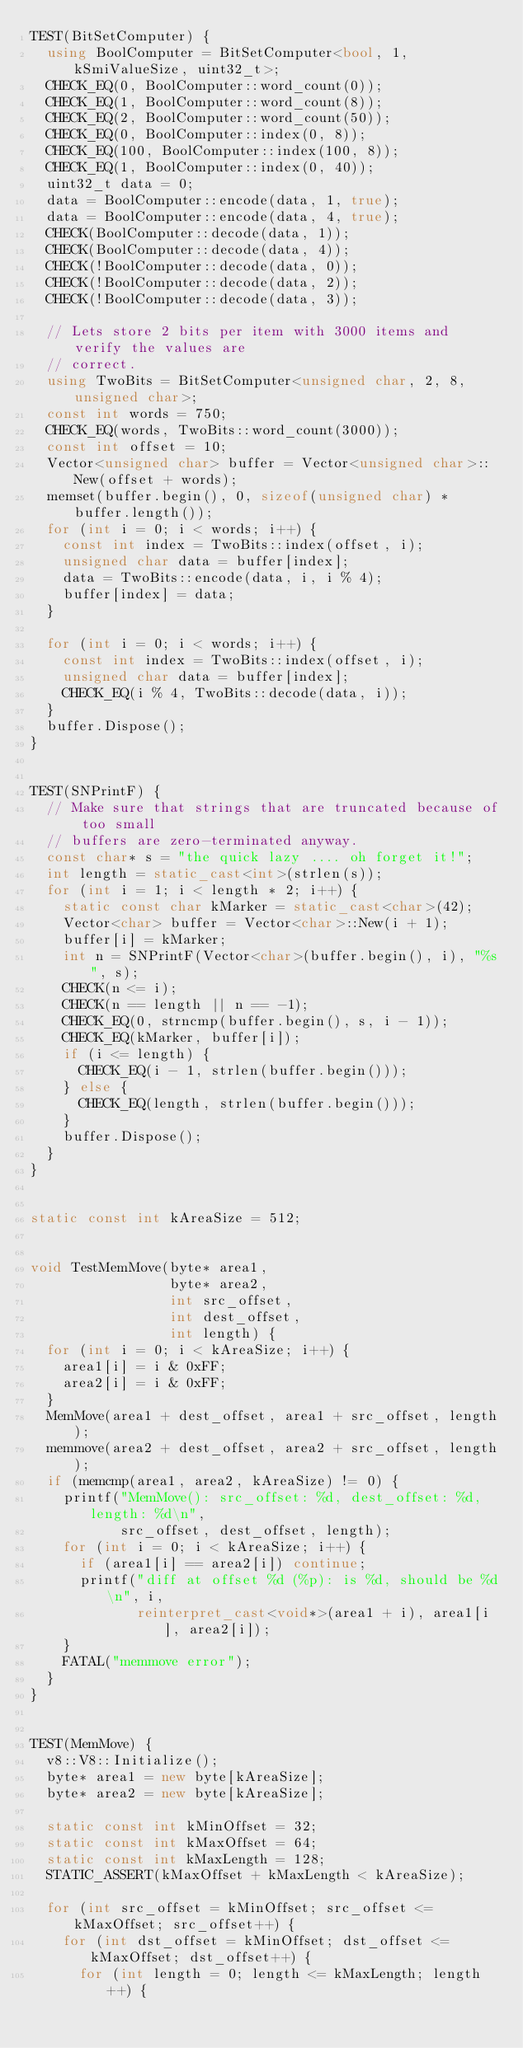<code> <loc_0><loc_0><loc_500><loc_500><_C++_>TEST(BitSetComputer) {
  using BoolComputer = BitSetComputer<bool, 1, kSmiValueSize, uint32_t>;
  CHECK_EQ(0, BoolComputer::word_count(0));
  CHECK_EQ(1, BoolComputer::word_count(8));
  CHECK_EQ(2, BoolComputer::word_count(50));
  CHECK_EQ(0, BoolComputer::index(0, 8));
  CHECK_EQ(100, BoolComputer::index(100, 8));
  CHECK_EQ(1, BoolComputer::index(0, 40));
  uint32_t data = 0;
  data = BoolComputer::encode(data, 1, true);
  data = BoolComputer::encode(data, 4, true);
  CHECK(BoolComputer::decode(data, 1));
  CHECK(BoolComputer::decode(data, 4));
  CHECK(!BoolComputer::decode(data, 0));
  CHECK(!BoolComputer::decode(data, 2));
  CHECK(!BoolComputer::decode(data, 3));

  // Lets store 2 bits per item with 3000 items and verify the values are
  // correct.
  using TwoBits = BitSetComputer<unsigned char, 2, 8, unsigned char>;
  const int words = 750;
  CHECK_EQ(words, TwoBits::word_count(3000));
  const int offset = 10;
  Vector<unsigned char> buffer = Vector<unsigned char>::New(offset + words);
  memset(buffer.begin(), 0, sizeof(unsigned char) * buffer.length());
  for (int i = 0; i < words; i++) {
    const int index = TwoBits::index(offset, i);
    unsigned char data = buffer[index];
    data = TwoBits::encode(data, i, i % 4);
    buffer[index] = data;
  }

  for (int i = 0; i < words; i++) {
    const int index = TwoBits::index(offset, i);
    unsigned char data = buffer[index];
    CHECK_EQ(i % 4, TwoBits::decode(data, i));
  }
  buffer.Dispose();
}


TEST(SNPrintF) {
  // Make sure that strings that are truncated because of too small
  // buffers are zero-terminated anyway.
  const char* s = "the quick lazy .... oh forget it!";
  int length = static_cast<int>(strlen(s));
  for (int i = 1; i < length * 2; i++) {
    static const char kMarker = static_cast<char>(42);
    Vector<char> buffer = Vector<char>::New(i + 1);
    buffer[i] = kMarker;
    int n = SNPrintF(Vector<char>(buffer.begin(), i), "%s", s);
    CHECK(n <= i);
    CHECK(n == length || n == -1);
    CHECK_EQ(0, strncmp(buffer.begin(), s, i - 1));
    CHECK_EQ(kMarker, buffer[i]);
    if (i <= length) {
      CHECK_EQ(i - 1, strlen(buffer.begin()));
    } else {
      CHECK_EQ(length, strlen(buffer.begin()));
    }
    buffer.Dispose();
  }
}


static const int kAreaSize = 512;


void TestMemMove(byte* area1,
                 byte* area2,
                 int src_offset,
                 int dest_offset,
                 int length) {
  for (int i = 0; i < kAreaSize; i++) {
    area1[i] = i & 0xFF;
    area2[i] = i & 0xFF;
  }
  MemMove(area1 + dest_offset, area1 + src_offset, length);
  memmove(area2 + dest_offset, area2 + src_offset, length);
  if (memcmp(area1, area2, kAreaSize) != 0) {
    printf("MemMove(): src_offset: %d, dest_offset: %d, length: %d\n",
           src_offset, dest_offset, length);
    for (int i = 0; i < kAreaSize; i++) {
      if (area1[i] == area2[i]) continue;
      printf("diff at offset %d (%p): is %d, should be %d\n", i,
             reinterpret_cast<void*>(area1 + i), area1[i], area2[i]);
    }
    FATAL("memmove error");
  }
}


TEST(MemMove) {
  v8::V8::Initialize();
  byte* area1 = new byte[kAreaSize];
  byte* area2 = new byte[kAreaSize];

  static const int kMinOffset = 32;
  static const int kMaxOffset = 64;
  static const int kMaxLength = 128;
  STATIC_ASSERT(kMaxOffset + kMaxLength < kAreaSize);

  for (int src_offset = kMinOffset; src_offset <= kMaxOffset; src_offset++) {
    for (int dst_offset = kMinOffset; dst_offset <= kMaxOffset; dst_offset++) {
      for (int length = 0; length <= kMaxLength; length++) {</code> 